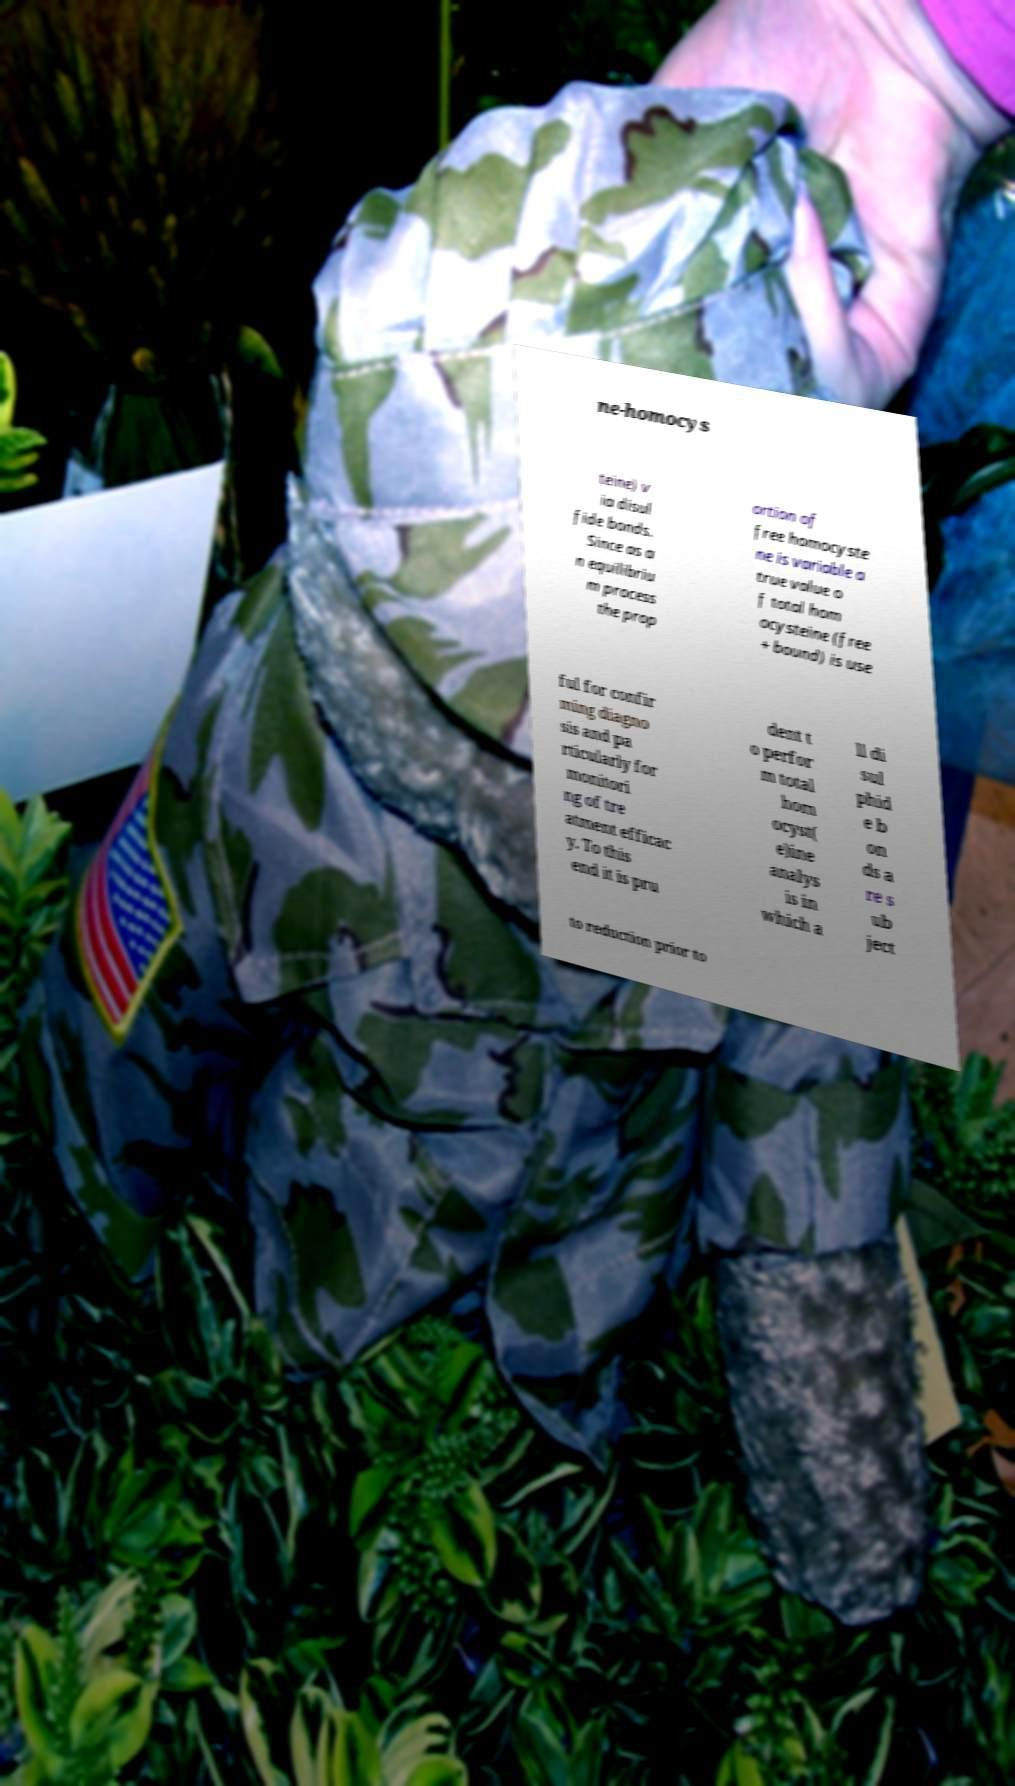Can you read and provide the text displayed in the image?This photo seems to have some interesting text. Can you extract and type it out for me? ne-homocys teine) v ia disul fide bonds. Since as a n equilibriu m process the prop ortion of free homocyste ne is variable a true value o f total hom ocysteine (free + bound) is use ful for confir ming diagno sis and pa rticularly for monitori ng of tre atment efficac y. To this end it is pru dent t o perfor m total hom ocyst( e)ine analys is in which a ll di sul phid e b on ds a re s ub ject to reduction prior to 